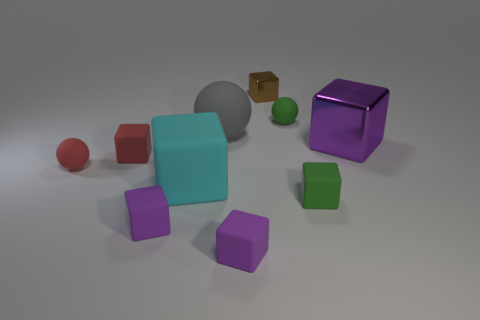Subtract all purple cubes. How many were subtracted if there are1purple cubes left? 2 Subtract all green balls. How many purple blocks are left? 3 Subtract 4 blocks. How many blocks are left? 3 Subtract all tiny metallic blocks. How many blocks are left? 6 Subtract all cyan blocks. How many blocks are left? 6 Subtract all red cubes. Subtract all brown cylinders. How many cubes are left? 6 Subtract all balls. How many objects are left? 7 Subtract 0 gray blocks. How many objects are left? 10 Subtract all tiny red objects. Subtract all large cyan blocks. How many objects are left? 7 Add 3 metal cubes. How many metal cubes are left? 5 